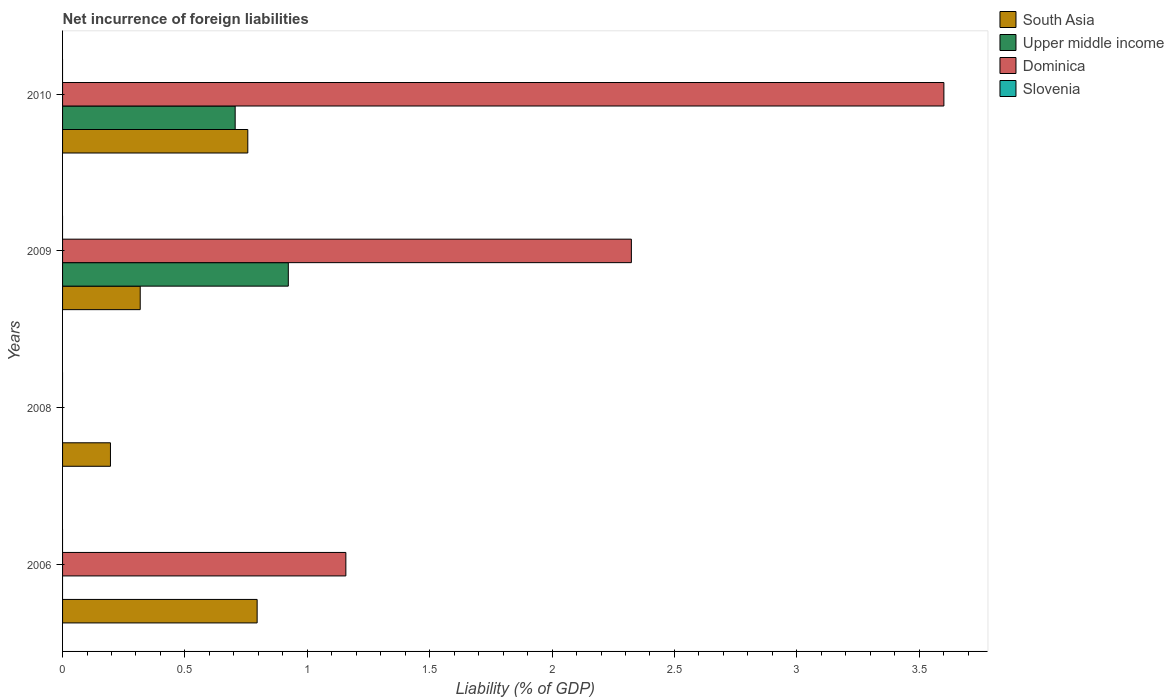How many bars are there on the 4th tick from the top?
Make the answer very short. 2. What is the net incurrence of foreign liabilities in Dominica in 2010?
Your answer should be very brief. 3.6. Across all years, what is the maximum net incurrence of foreign liabilities in South Asia?
Your response must be concise. 0.8. Across all years, what is the minimum net incurrence of foreign liabilities in South Asia?
Make the answer very short. 0.2. In which year was the net incurrence of foreign liabilities in South Asia maximum?
Your response must be concise. 2006. What is the total net incurrence of foreign liabilities in Dominica in the graph?
Give a very brief answer. 7.08. What is the difference between the net incurrence of foreign liabilities in Dominica in 2006 and that in 2009?
Your response must be concise. -1.17. What is the difference between the net incurrence of foreign liabilities in Upper middle income in 2006 and the net incurrence of foreign liabilities in Dominica in 2010?
Offer a terse response. -3.6. What is the average net incurrence of foreign liabilities in Upper middle income per year?
Your answer should be compact. 0.41. In the year 2010, what is the difference between the net incurrence of foreign liabilities in Upper middle income and net incurrence of foreign liabilities in South Asia?
Give a very brief answer. -0.05. What is the ratio of the net incurrence of foreign liabilities in Dominica in 2006 to that in 2009?
Provide a succinct answer. 0.5. What is the difference between the highest and the second highest net incurrence of foreign liabilities in Dominica?
Offer a very short reply. 1.28. What is the difference between the highest and the lowest net incurrence of foreign liabilities in Upper middle income?
Keep it short and to the point. 0.92. In how many years, is the net incurrence of foreign liabilities in Upper middle income greater than the average net incurrence of foreign liabilities in Upper middle income taken over all years?
Provide a short and direct response. 2. Is the sum of the net incurrence of foreign liabilities in South Asia in 2009 and 2010 greater than the maximum net incurrence of foreign liabilities in Slovenia across all years?
Your response must be concise. Yes. Is it the case that in every year, the sum of the net incurrence of foreign liabilities in Dominica and net incurrence of foreign liabilities in Slovenia is greater than the net incurrence of foreign liabilities in South Asia?
Provide a short and direct response. No. Are all the bars in the graph horizontal?
Give a very brief answer. Yes. How many years are there in the graph?
Ensure brevity in your answer.  4. What is the difference between two consecutive major ticks on the X-axis?
Give a very brief answer. 0.5. Are the values on the major ticks of X-axis written in scientific E-notation?
Offer a very short reply. No. Where does the legend appear in the graph?
Your answer should be compact. Top right. How many legend labels are there?
Your response must be concise. 4. How are the legend labels stacked?
Offer a very short reply. Vertical. What is the title of the graph?
Provide a succinct answer. Net incurrence of foreign liabilities. What is the label or title of the X-axis?
Your response must be concise. Liability (% of GDP). What is the Liability (% of GDP) in South Asia in 2006?
Your answer should be very brief. 0.8. What is the Liability (% of GDP) of Dominica in 2006?
Provide a short and direct response. 1.16. What is the Liability (% of GDP) in Slovenia in 2006?
Keep it short and to the point. 0. What is the Liability (% of GDP) of South Asia in 2008?
Give a very brief answer. 0.2. What is the Liability (% of GDP) of Upper middle income in 2008?
Provide a succinct answer. 0. What is the Liability (% of GDP) of South Asia in 2009?
Make the answer very short. 0.32. What is the Liability (% of GDP) in Upper middle income in 2009?
Provide a short and direct response. 0.92. What is the Liability (% of GDP) in Dominica in 2009?
Your answer should be very brief. 2.32. What is the Liability (% of GDP) in South Asia in 2010?
Provide a succinct answer. 0.76. What is the Liability (% of GDP) in Upper middle income in 2010?
Ensure brevity in your answer.  0.71. What is the Liability (% of GDP) of Dominica in 2010?
Your response must be concise. 3.6. What is the Liability (% of GDP) in Slovenia in 2010?
Make the answer very short. 0. Across all years, what is the maximum Liability (% of GDP) in South Asia?
Offer a very short reply. 0.8. Across all years, what is the maximum Liability (% of GDP) of Upper middle income?
Give a very brief answer. 0.92. Across all years, what is the maximum Liability (% of GDP) in Dominica?
Offer a terse response. 3.6. Across all years, what is the minimum Liability (% of GDP) of South Asia?
Give a very brief answer. 0.2. Across all years, what is the minimum Liability (% of GDP) of Upper middle income?
Make the answer very short. 0. Across all years, what is the minimum Liability (% of GDP) in Dominica?
Ensure brevity in your answer.  0. What is the total Liability (% of GDP) of South Asia in the graph?
Make the answer very short. 2.06. What is the total Liability (% of GDP) of Upper middle income in the graph?
Offer a very short reply. 1.63. What is the total Liability (% of GDP) in Dominica in the graph?
Keep it short and to the point. 7.08. What is the difference between the Liability (% of GDP) in South Asia in 2006 and that in 2008?
Make the answer very short. 0.6. What is the difference between the Liability (% of GDP) of South Asia in 2006 and that in 2009?
Your response must be concise. 0.48. What is the difference between the Liability (% of GDP) of Dominica in 2006 and that in 2009?
Give a very brief answer. -1.17. What is the difference between the Liability (% of GDP) of South Asia in 2006 and that in 2010?
Your response must be concise. 0.04. What is the difference between the Liability (% of GDP) of Dominica in 2006 and that in 2010?
Your answer should be very brief. -2.44. What is the difference between the Liability (% of GDP) of South Asia in 2008 and that in 2009?
Offer a very short reply. -0.12. What is the difference between the Liability (% of GDP) in South Asia in 2008 and that in 2010?
Make the answer very short. -0.56. What is the difference between the Liability (% of GDP) in South Asia in 2009 and that in 2010?
Offer a terse response. -0.44. What is the difference between the Liability (% of GDP) of Upper middle income in 2009 and that in 2010?
Make the answer very short. 0.22. What is the difference between the Liability (% of GDP) in Dominica in 2009 and that in 2010?
Ensure brevity in your answer.  -1.28. What is the difference between the Liability (% of GDP) of South Asia in 2006 and the Liability (% of GDP) of Upper middle income in 2009?
Keep it short and to the point. -0.13. What is the difference between the Liability (% of GDP) of South Asia in 2006 and the Liability (% of GDP) of Dominica in 2009?
Your response must be concise. -1.53. What is the difference between the Liability (% of GDP) of South Asia in 2006 and the Liability (% of GDP) of Upper middle income in 2010?
Offer a terse response. 0.09. What is the difference between the Liability (% of GDP) of South Asia in 2006 and the Liability (% of GDP) of Dominica in 2010?
Your response must be concise. -2.81. What is the difference between the Liability (% of GDP) in South Asia in 2008 and the Liability (% of GDP) in Upper middle income in 2009?
Your answer should be very brief. -0.73. What is the difference between the Liability (% of GDP) in South Asia in 2008 and the Liability (% of GDP) in Dominica in 2009?
Your answer should be very brief. -2.13. What is the difference between the Liability (% of GDP) in South Asia in 2008 and the Liability (% of GDP) in Upper middle income in 2010?
Offer a terse response. -0.51. What is the difference between the Liability (% of GDP) of South Asia in 2008 and the Liability (% of GDP) of Dominica in 2010?
Keep it short and to the point. -3.41. What is the difference between the Liability (% of GDP) in South Asia in 2009 and the Liability (% of GDP) in Upper middle income in 2010?
Offer a terse response. -0.39. What is the difference between the Liability (% of GDP) in South Asia in 2009 and the Liability (% of GDP) in Dominica in 2010?
Your answer should be compact. -3.28. What is the difference between the Liability (% of GDP) in Upper middle income in 2009 and the Liability (% of GDP) in Dominica in 2010?
Your answer should be compact. -2.68. What is the average Liability (% of GDP) in South Asia per year?
Make the answer very short. 0.52. What is the average Liability (% of GDP) in Upper middle income per year?
Make the answer very short. 0.41. What is the average Liability (% of GDP) of Dominica per year?
Your answer should be compact. 1.77. What is the average Liability (% of GDP) of Slovenia per year?
Offer a terse response. 0. In the year 2006, what is the difference between the Liability (% of GDP) in South Asia and Liability (% of GDP) in Dominica?
Give a very brief answer. -0.36. In the year 2009, what is the difference between the Liability (% of GDP) in South Asia and Liability (% of GDP) in Upper middle income?
Your answer should be compact. -0.6. In the year 2009, what is the difference between the Liability (% of GDP) of South Asia and Liability (% of GDP) of Dominica?
Make the answer very short. -2.01. In the year 2009, what is the difference between the Liability (% of GDP) in Upper middle income and Liability (% of GDP) in Dominica?
Ensure brevity in your answer.  -1.4. In the year 2010, what is the difference between the Liability (% of GDP) of South Asia and Liability (% of GDP) of Upper middle income?
Your response must be concise. 0.05. In the year 2010, what is the difference between the Liability (% of GDP) in South Asia and Liability (% of GDP) in Dominica?
Offer a terse response. -2.84. In the year 2010, what is the difference between the Liability (% of GDP) in Upper middle income and Liability (% of GDP) in Dominica?
Provide a short and direct response. -2.9. What is the ratio of the Liability (% of GDP) of South Asia in 2006 to that in 2008?
Give a very brief answer. 4.06. What is the ratio of the Liability (% of GDP) of South Asia in 2006 to that in 2009?
Provide a succinct answer. 2.51. What is the ratio of the Liability (% of GDP) of Dominica in 2006 to that in 2009?
Keep it short and to the point. 0.5. What is the ratio of the Liability (% of GDP) in South Asia in 2006 to that in 2010?
Your response must be concise. 1.05. What is the ratio of the Liability (% of GDP) of Dominica in 2006 to that in 2010?
Your answer should be very brief. 0.32. What is the ratio of the Liability (% of GDP) of South Asia in 2008 to that in 2009?
Make the answer very short. 0.62. What is the ratio of the Liability (% of GDP) in South Asia in 2008 to that in 2010?
Ensure brevity in your answer.  0.26. What is the ratio of the Liability (% of GDP) in South Asia in 2009 to that in 2010?
Ensure brevity in your answer.  0.42. What is the ratio of the Liability (% of GDP) of Upper middle income in 2009 to that in 2010?
Make the answer very short. 1.31. What is the ratio of the Liability (% of GDP) of Dominica in 2009 to that in 2010?
Make the answer very short. 0.65. What is the difference between the highest and the second highest Liability (% of GDP) of South Asia?
Give a very brief answer. 0.04. What is the difference between the highest and the second highest Liability (% of GDP) in Dominica?
Keep it short and to the point. 1.28. What is the difference between the highest and the lowest Liability (% of GDP) of South Asia?
Your answer should be compact. 0.6. What is the difference between the highest and the lowest Liability (% of GDP) of Upper middle income?
Provide a short and direct response. 0.92. What is the difference between the highest and the lowest Liability (% of GDP) of Dominica?
Give a very brief answer. 3.6. 